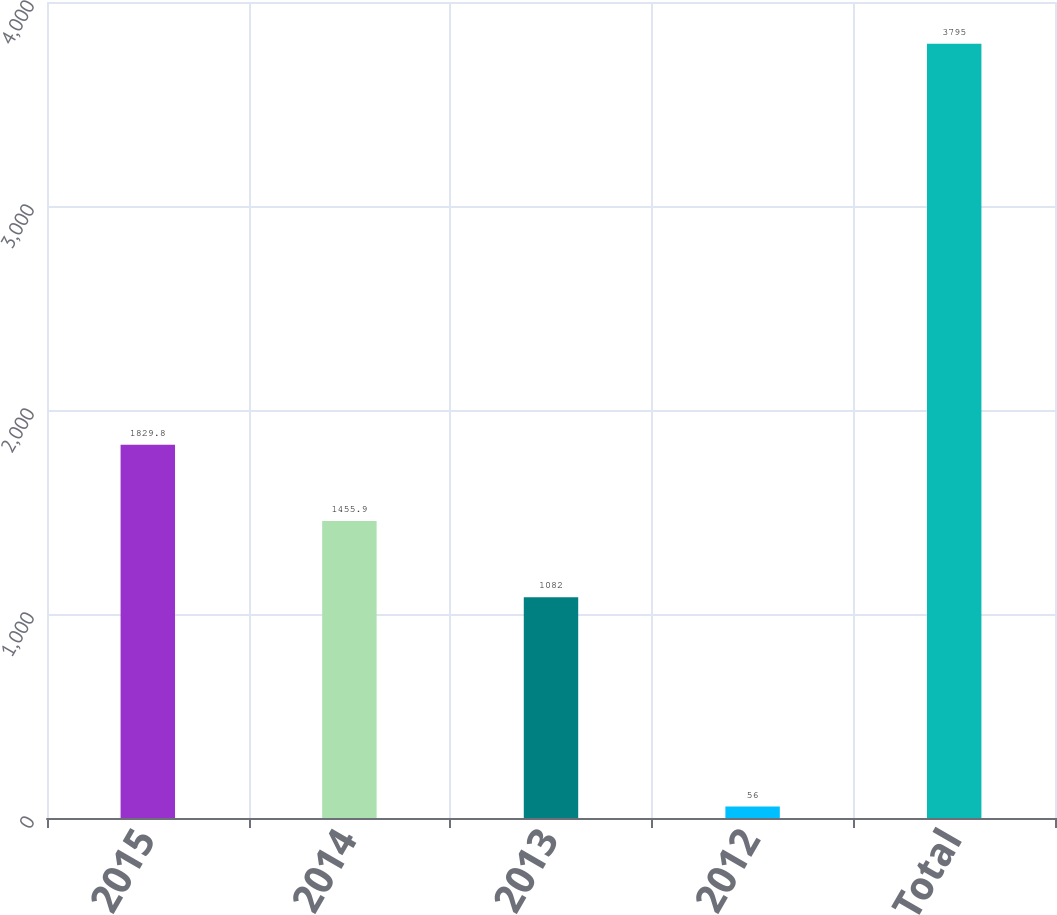<chart> <loc_0><loc_0><loc_500><loc_500><bar_chart><fcel>2015<fcel>2014<fcel>2013<fcel>2012<fcel>Total<nl><fcel>1829.8<fcel>1455.9<fcel>1082<fcel>56<fcel>3795<nl></chart> 